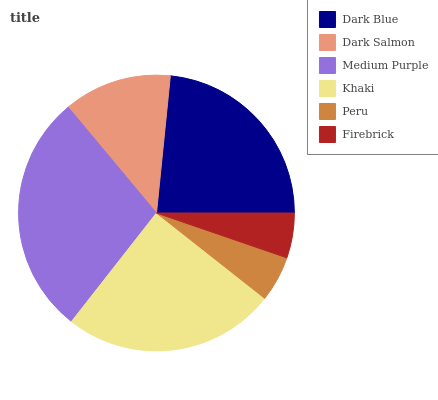Is Firebrick the minimum?
Answer yes or no. Yes. Is Medium Purple the maximum?
Answer yes or no. Yes. Is Dark Salmon the minimum?
Answer yes or no. No. Is Dark Salmon the maximum?
Answer yes or no. No. Is Dark Blue greater than Dark Salmon?
Answer yes or no. Yes. Is Dark Salmon less than Dark Blue?
Answer yes or no. Yes. Is Dark Salmon greater than Dark Blue?
Answer yes or no. No. Is Dark Blue less than Dark Salmon?
Answer yes or no. No. Is Dark Blue the high median?
Answer yes or no. Yes. Is Dark Salmon the low median?
Answer yes or no. Yes. Is Medium Purple the high median?
Answer yes or no. No. Is Dark Blue the low median?
Answer yes or no. No. 